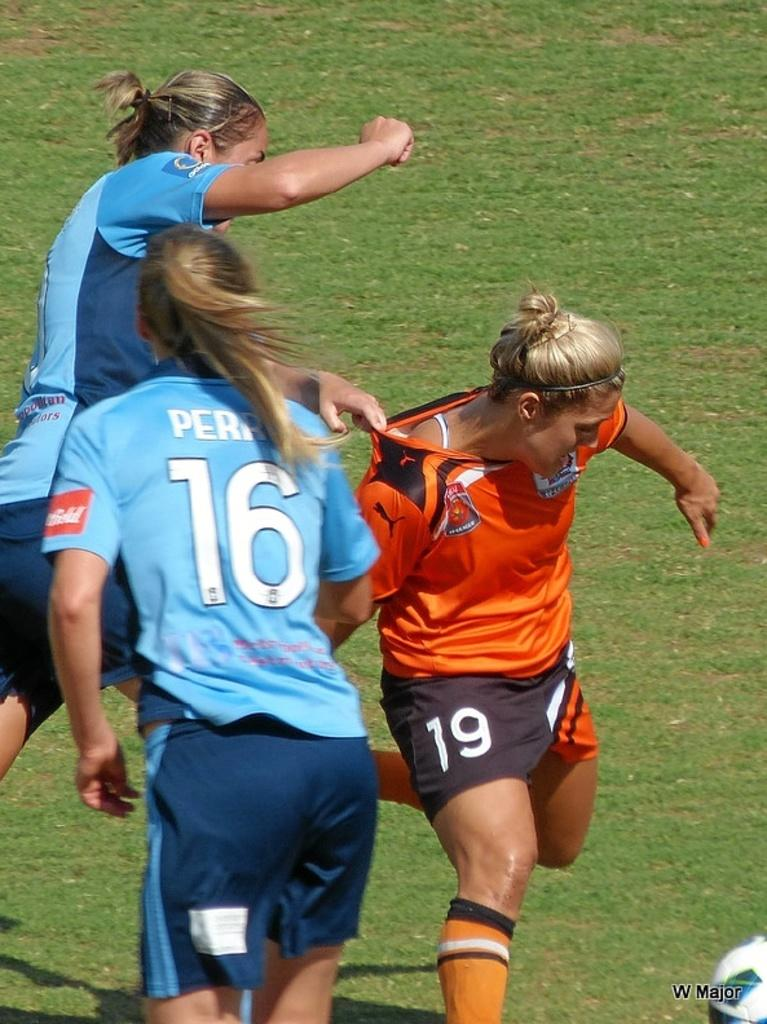<image>
Present a compact description of the photo's key features. Female soccer players wearing numbers such as 16 and 19 jostling for the soccer ball. 